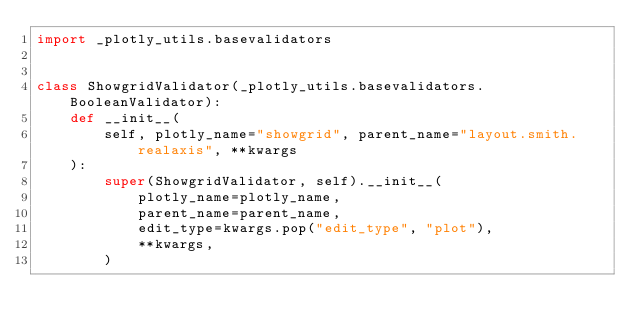<code> <loc_0><loc_0><loc_500><loc_500><_Python_>import _plotly_utils.basevalidators


class ShowgridValidator(_plotly_utils.basevalidators.BooleanValidator):
    def __init__(
        self, plotly_name="showgrid", parent_name="layout.smith.realaxis", **kwargs
    ):
        super(ShowgridValidator, self).__init__(
            plotly_name=plotly_name,
            parent_name=parent_name,
            edit_type=kwargs.pop("edit_type", "plot"),
            **kwargs,
        )
</code> 